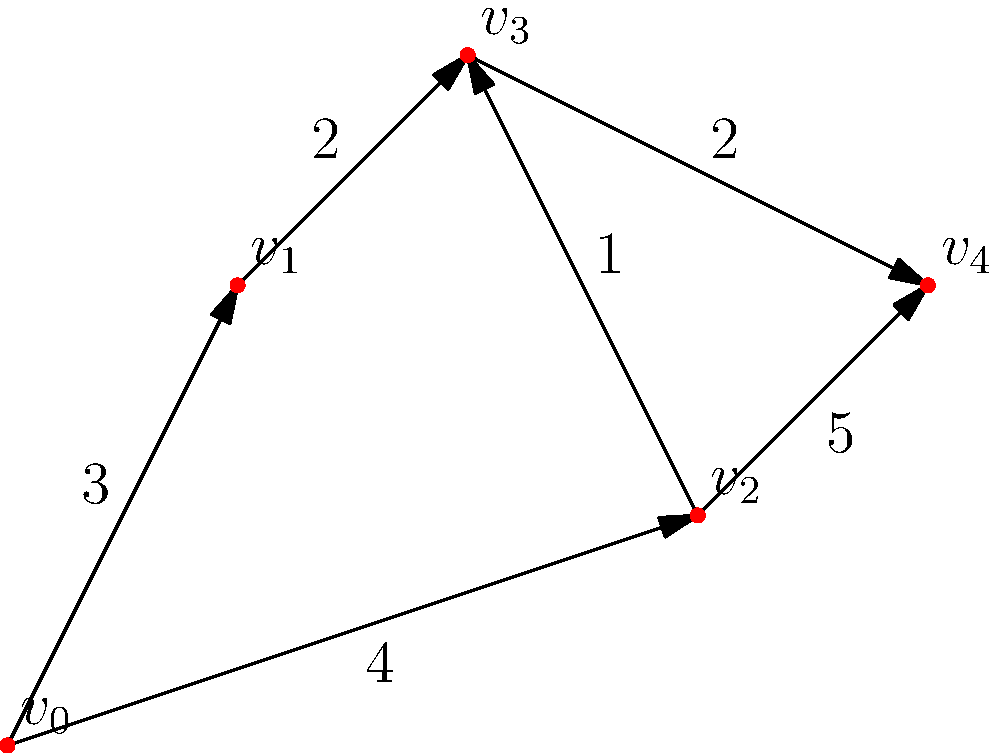In an urban landscape, you're tasked with finding the most efficient route for distributing resources from a central hub ($v_0$) to a key distribution point ($v_4$). The graph represents different city zones, with edges indicating available routes and their associated costs. What is the total cost of the shortest path from $v_0$ to $v_4$? To find the shortest path from $v_0$ to $v_4$, we'll use Dijkstra's algorithm:

1. Initialize distances: $d(v_0) = 0$, all others $\infty$
2. Set $v_0$ as the current vertex
3. For each neighbor of the current vertex:
   - Calculate tentative distance
   - If tentative distance < current distance, update
4. Mark current vertex as visited
5. Set unvisited vertex with smallest distance as current
6. Repeat steps 3-5 until $v_4$ is reached

Step-by-step:
1. Start at $v_0$: $d(v_0) = 0$, $d(v_1) = 3$, $d(v_2) = 4$
2. Visit $v_1$: $d(v_3) = 3 + 2 = 5$
3. Visit $v_2$: $d(v_3) = \min(5, 4 + 1) = 5$, $d(v_4) = 4 + 5 = 9$
4. Visit $v_3$: $d(v_4) = \min(9, 5 + 2) = 7$
5. Visit $v_4$: Destination reached

The shortest path is $v_0 \rightarrow v_2 \rightarrow v_3 \rightarrow v_4$ with a total cost of $4 + 1 + 2 = 7$.
Answer: 7 